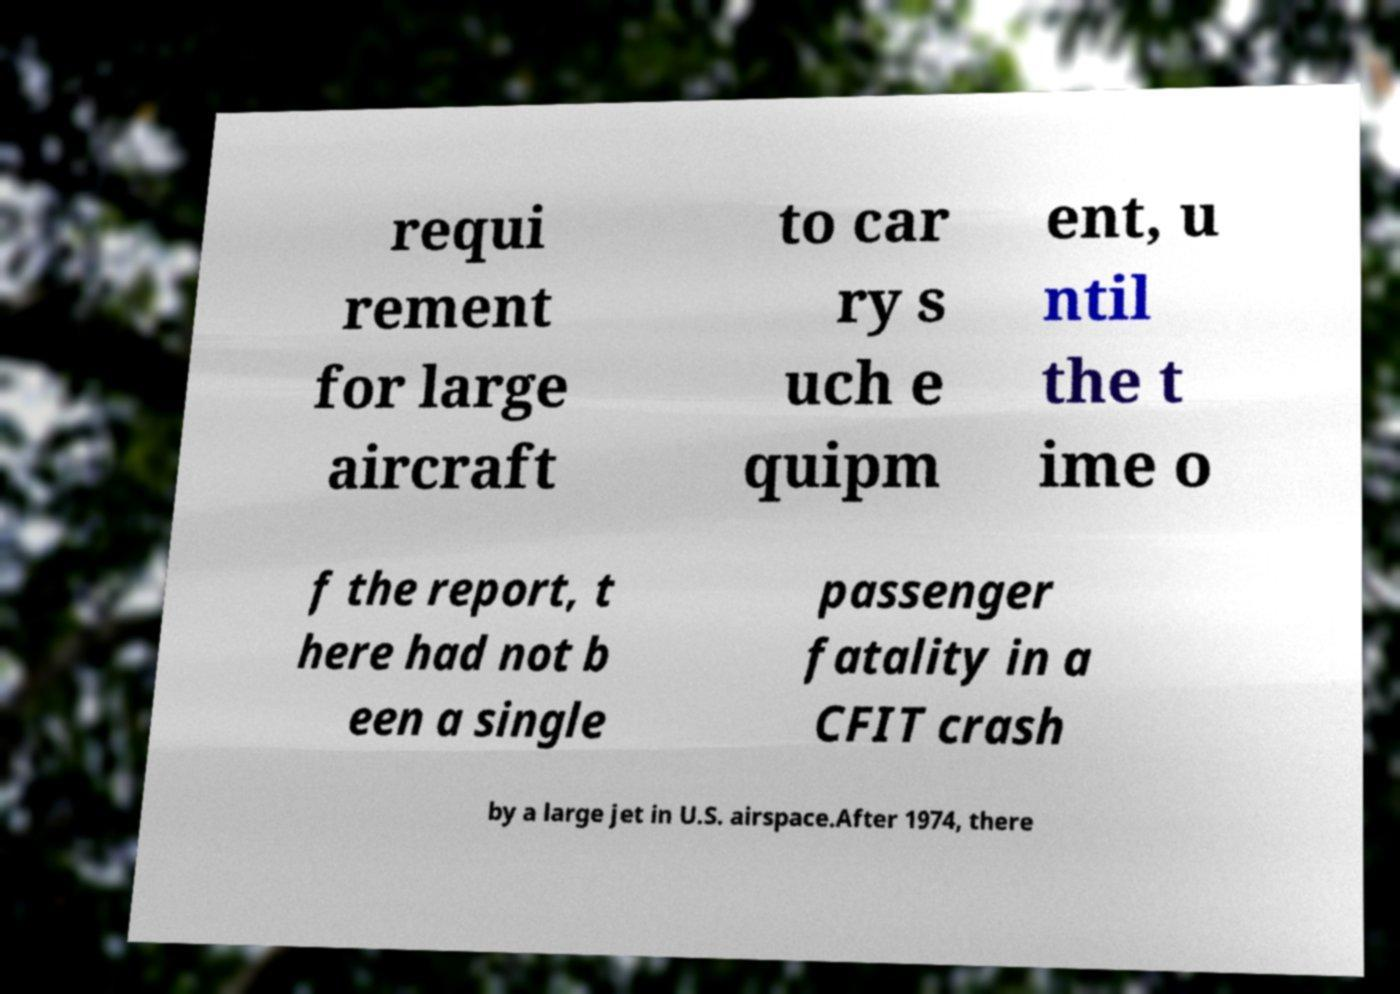Please read and relay the text visible in this image. What does it say? requi rement for large aircraft to car ry s uch e quipm ent, u ntil the t ime o f the report, t here had not b een a single passenger fatality in a CFIT crash by a large jet in U.S. airspace.After 1974, there 